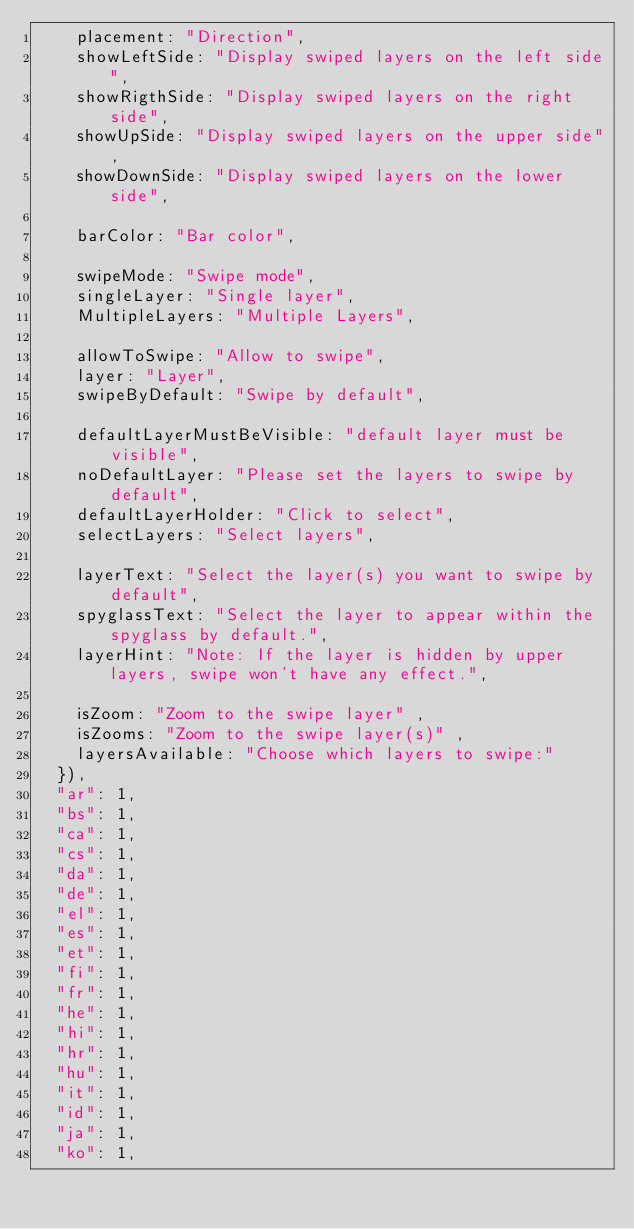<code> <loc_0><loc_0><loc_500><loc_500><_JavaScript_>    placement: "Direction",
    showLeftSide: "Display swiped layers on the left side",
    showRigthSide: "Display swiped layers on the right side",
    showUpSide: "Display swiped layers on the upper side",
    showDownSide: "Display swiped layers on the lower side",

    barColor: "Bar color",

    swipeMode: "Swipe mode",
    singleLayer: "Single layer",
    MultipleLayers: "Multiple Layers",

    allowToSwipe: "Allow to swipe",
    layer: "Layer",
    swipeByDefault: "Swipe by default",

    defaultLayerMustBeVisible: "default layer must be visible",
    noDefaultLayer: "Please set the layers to swipe by default",
    defaultLayerHolder: "Click to select",
    selectLayers: "Select layers",

    layerText: "Select the layer(s) you want to swipe by default",
    spyglassText: "Select the layer to appear within the spyglass by default.",
    layerHint: "Note: If the layer is hidden by upper layers, swipe won't have any effect.",

    isZoom: "Zoom to the swipe layer" ,
    isZooms: "Zoom to the swipe layer(s)" ,
    layersAvailable: "Choose which layers to swipe:"
  }),
  "ar": 1,
  "bs": 1,
  "ca": 1,
  "cs": 1,
  "da": 1,
  "de": 1,
  "el": 1,
  "es": 1,
  "et": 1,
  "fi": 1,
  "fr": 1,
  "he": 1,
  "hi": 1,
  "hr": 1,
  "hu": 1,
  "it": 1,
  "id": 1,
  "ja": 1,
  "ko": 1,</code> 